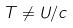<formula> <loc_0><loc_0><loc_500><loc_500>T \ne U / c</formula> 